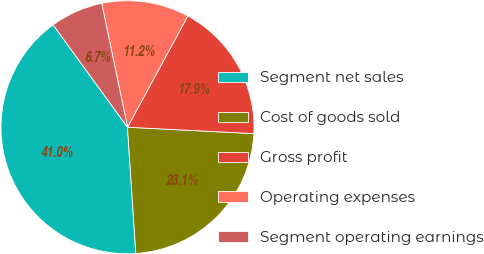<chart> <loc_0><loc_0><loc_500><loc_500><pie_chart><fcel>Segment net sales<fcel>Cost of goods sold<fcel>Gross profit<fcel>Operating expenses<fcel>Segment operating earnings<nl><fcel>41.05%<fcel>23.15%<fcel>17.9%<fcel>11.17%<fcel>6.73%<nl></chart> 